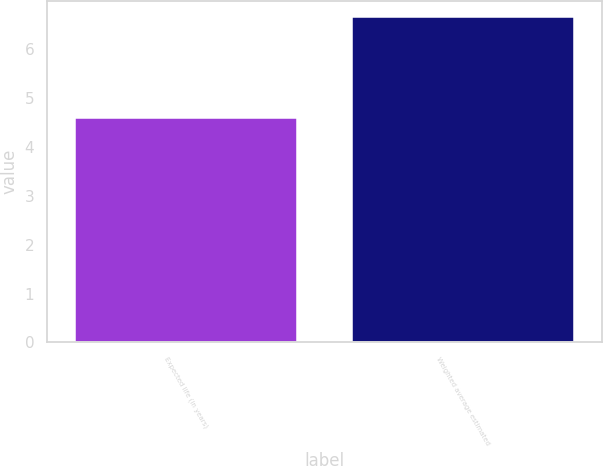Convert chart. <chart><loc_0><loc_0><loc_500><loc_500><bar_chart><fcel>Expected life (in years)<fcel>Weighted average estimated<nl><fcel>4.6<fcel>6.66<nl></chart> 